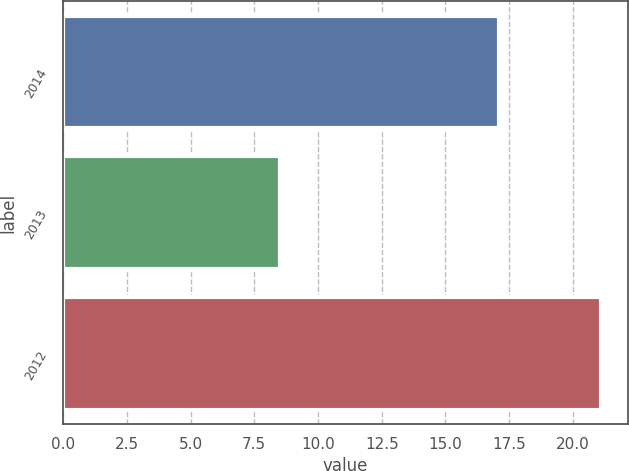Convert chart. <chart><loc_0><loc_0><loc_500><loc_500><bar_chart><fcel>2014<fcel>2013<fcel>2012<nl><fcel>17.1<fcel>8.5<fcel>21.1<nl></chart> 